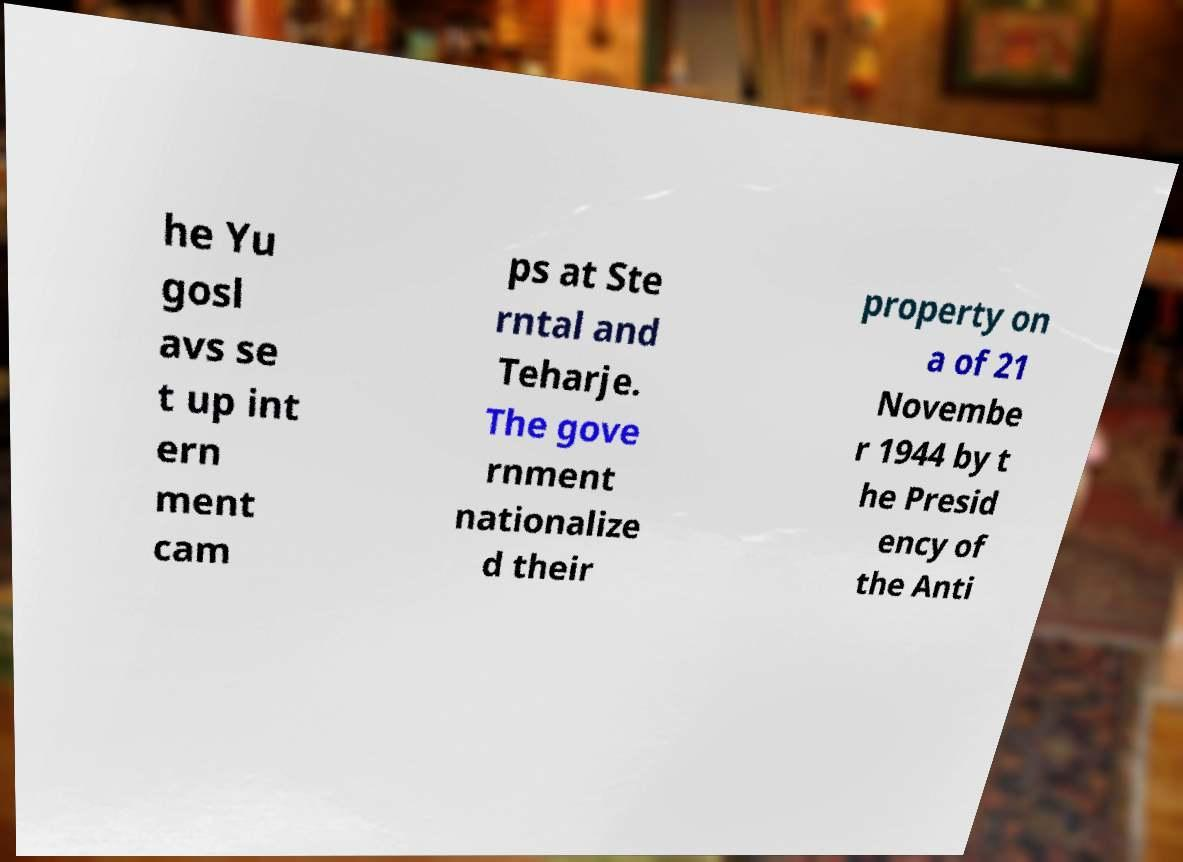For documentation purposes, I need the text within this image transcribed. Could you provide that? he Yu gosl avs se t up int ern ment cam ps at Ste rntal and Teharje. The gove rnment nationalize d their property on a of 21 Novembe r 1944 by t he Presid ency of the Anti 